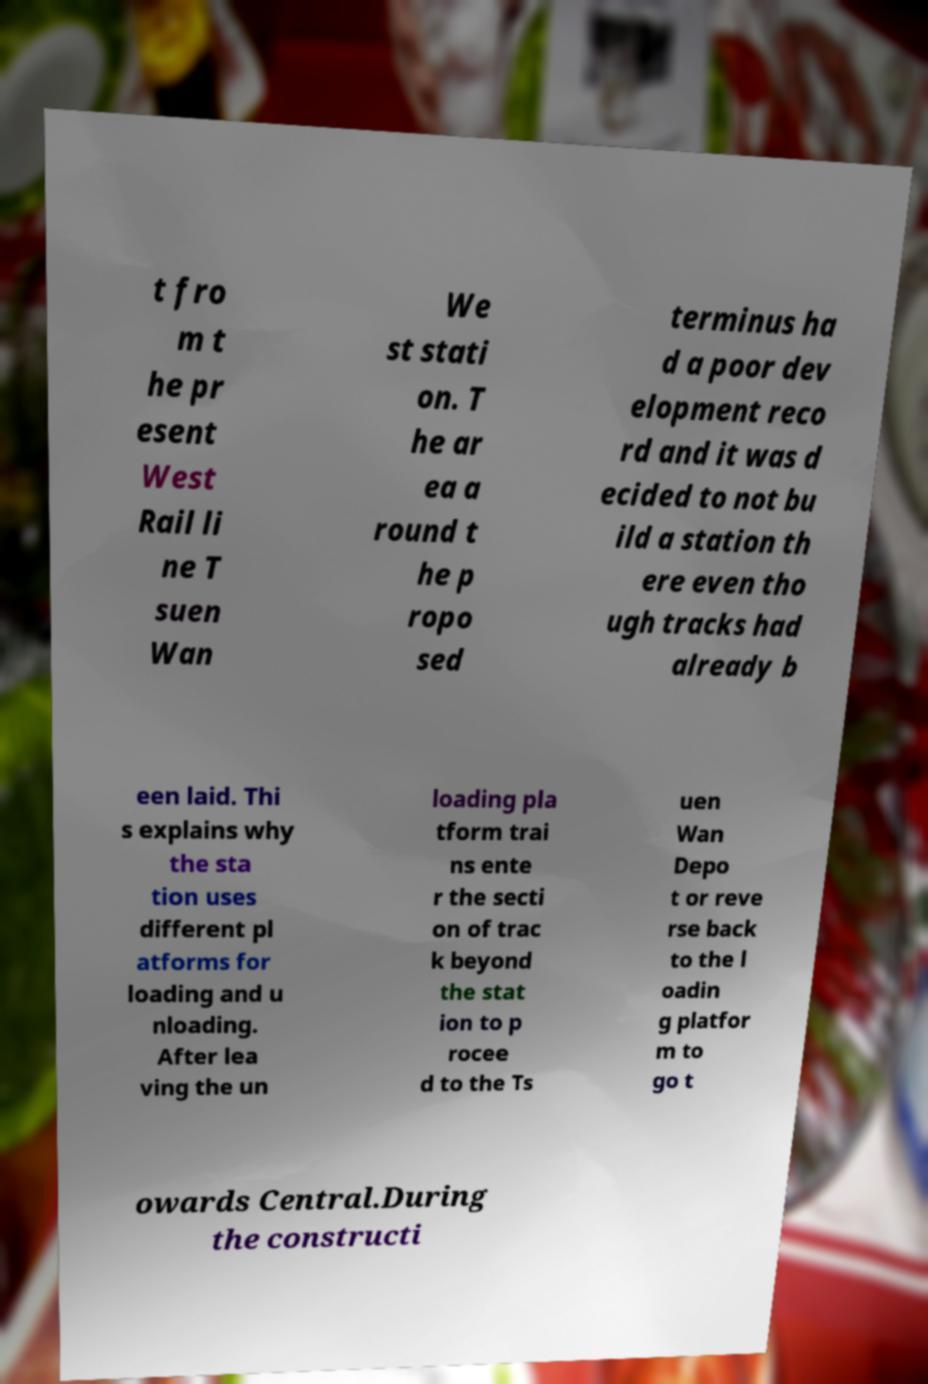Can you read and provide the text displayed in the image?This photo seems to have some interesting text. Can you extract and type it out for me? t fro m t he pr esent West Rail li ne T suen Wan We st stati on. T he ar ea a round t he p ropo sed terminus ha d a poor dev elopment reco rd and it was d ecided to not bu ild a station th ere even tho ugh tracks had already b een laid. Thi s explains why the sta tion uses different pl atforms for loading and u nloading. After lea ving the un loading pla tform trai ns ente r the secti on of trac k beyond the stat ion to p rocee d to the Ts uen Wan Depo t or reve rse back to the l oadin g platfor m to go t owards Central.During the constructi 